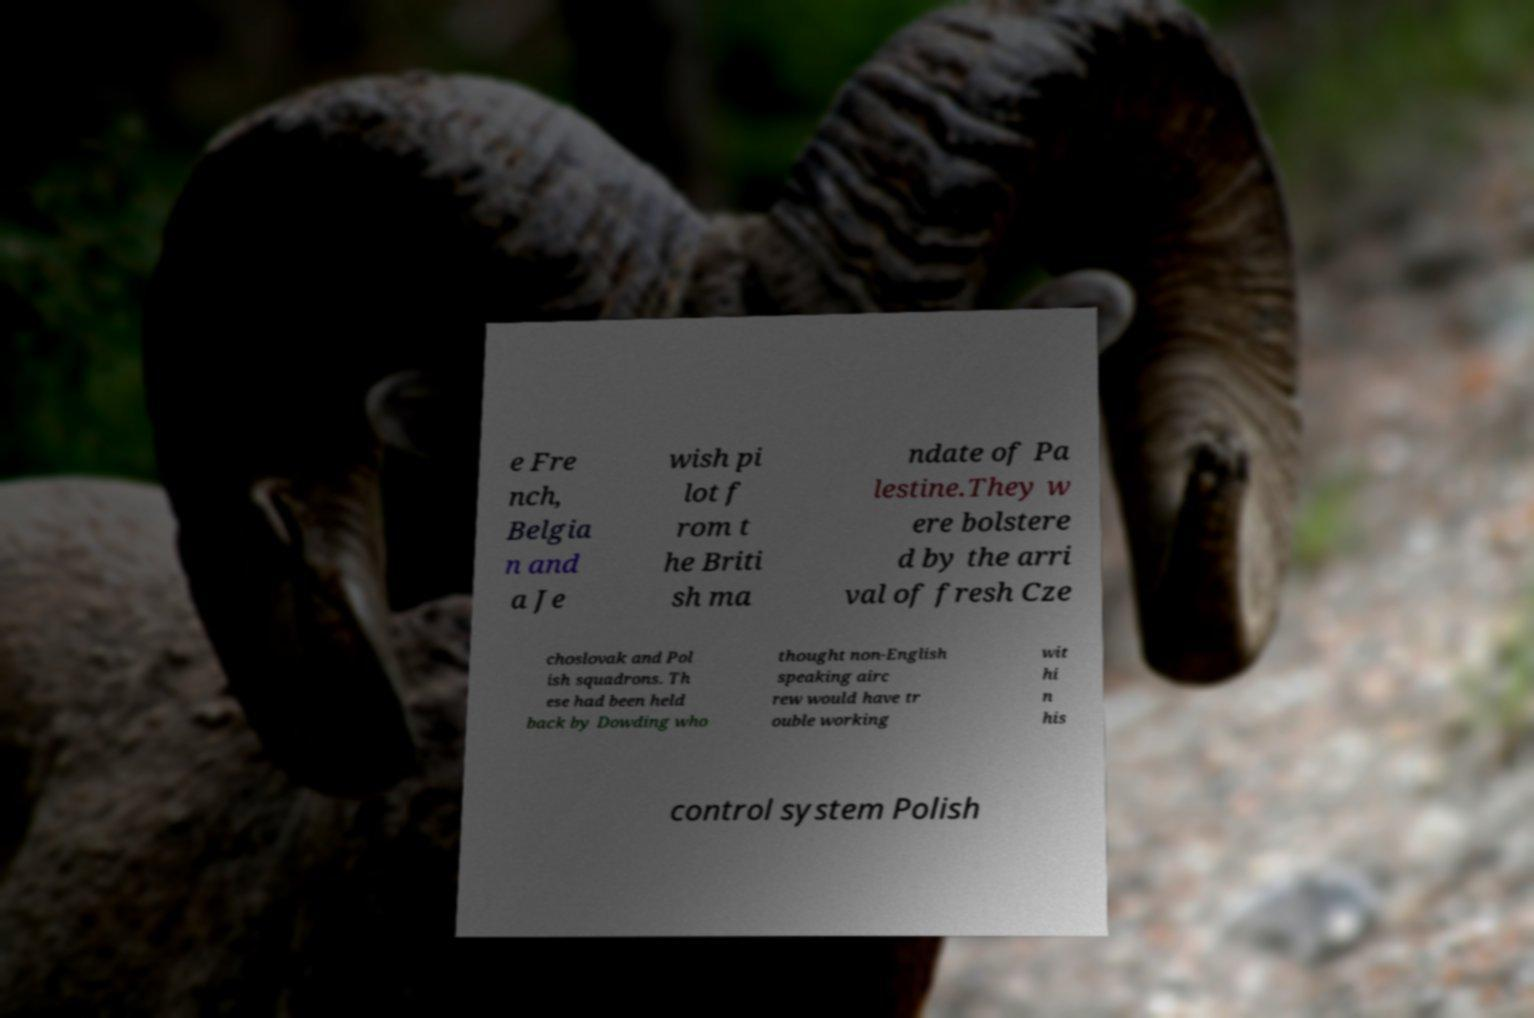I need the written content from this picture converted into text. Can you do that? e Fre nch, Belgia n and a Je wish pi lot f rom t he Briti sh ma ndate of Pa lestine.They w ere bolstere d by the arri val of fresh Cze choslovak and Pol ish squadrons. Th ese had been held back by Dowding who thought non-English speaking airc rew would have tr ouble working wit hi n his control system Polish 